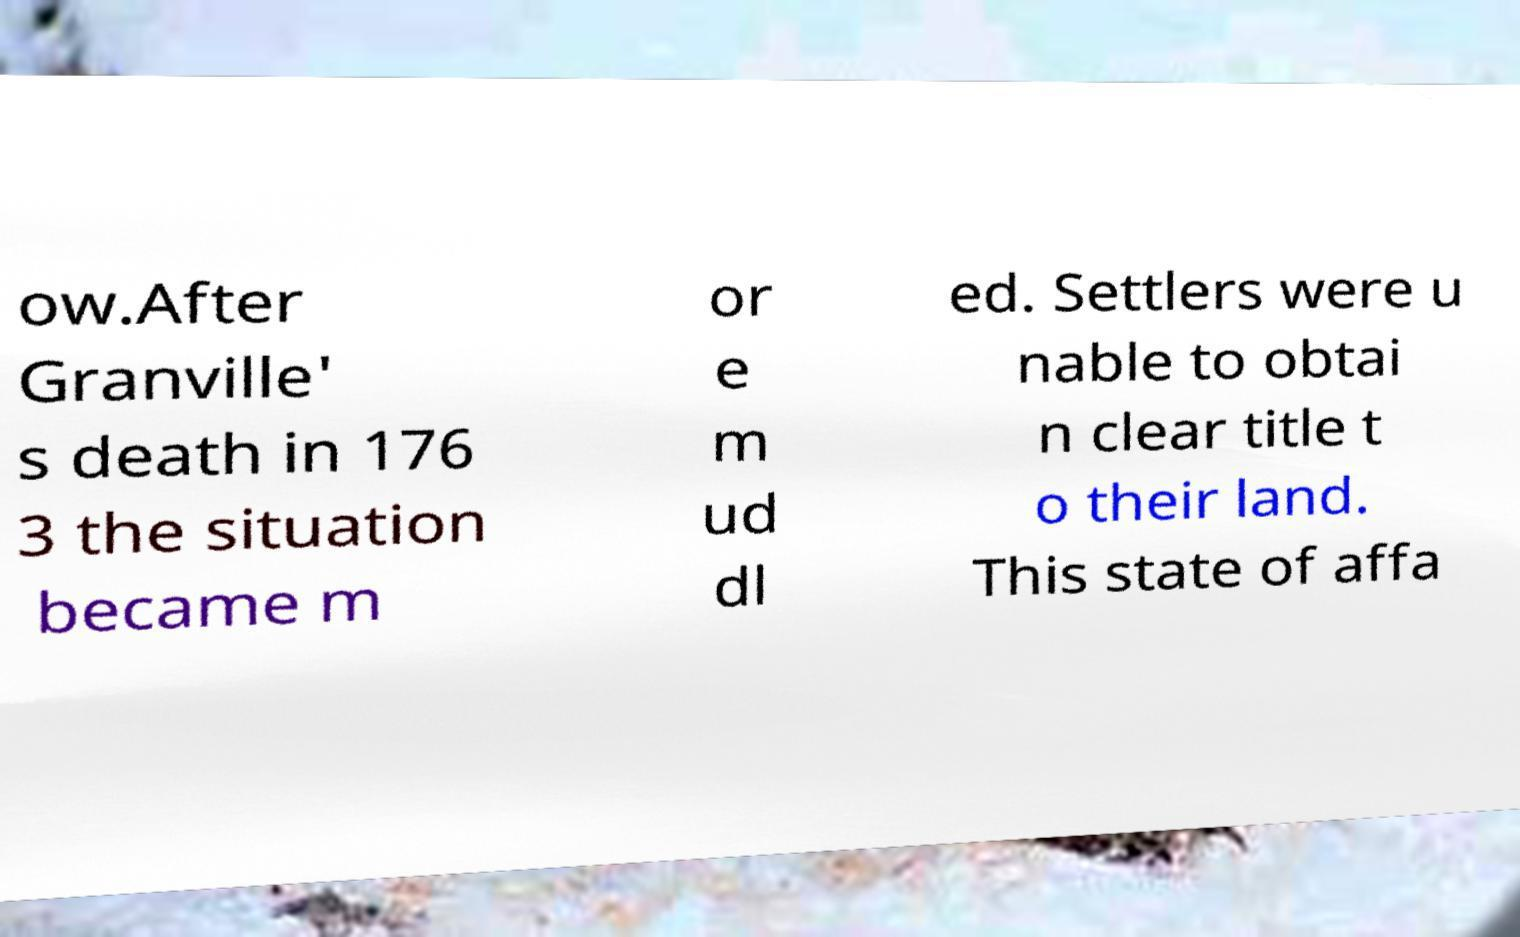There's text embedded in this image that I need extracted. Can you transcribe it verbatim? ow.After Granville' s death in 176 3 the situation became m or e m ud dl ed. Settlers were u nable to obtai n clear title t o their land. This state of affa 